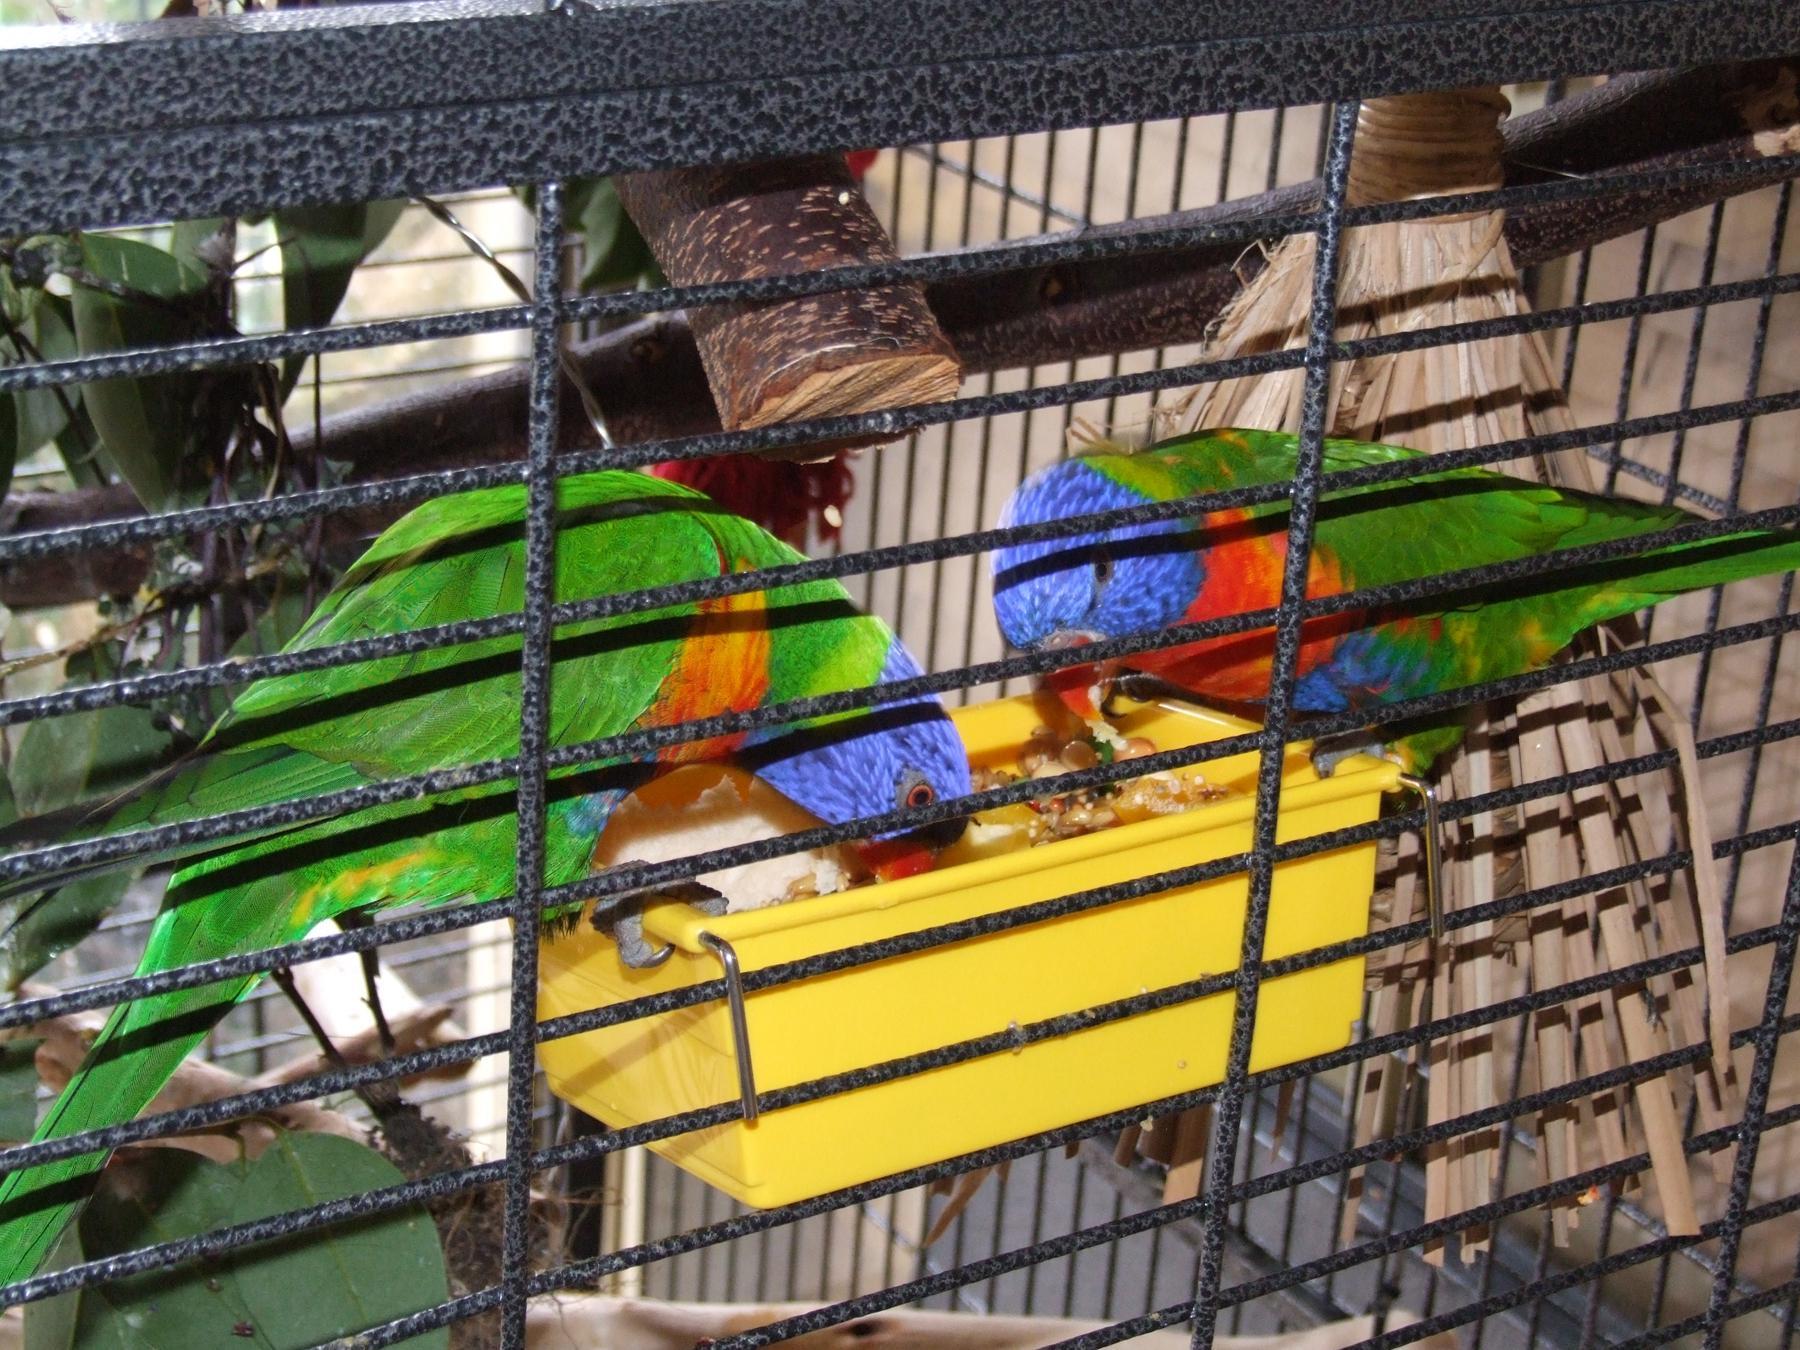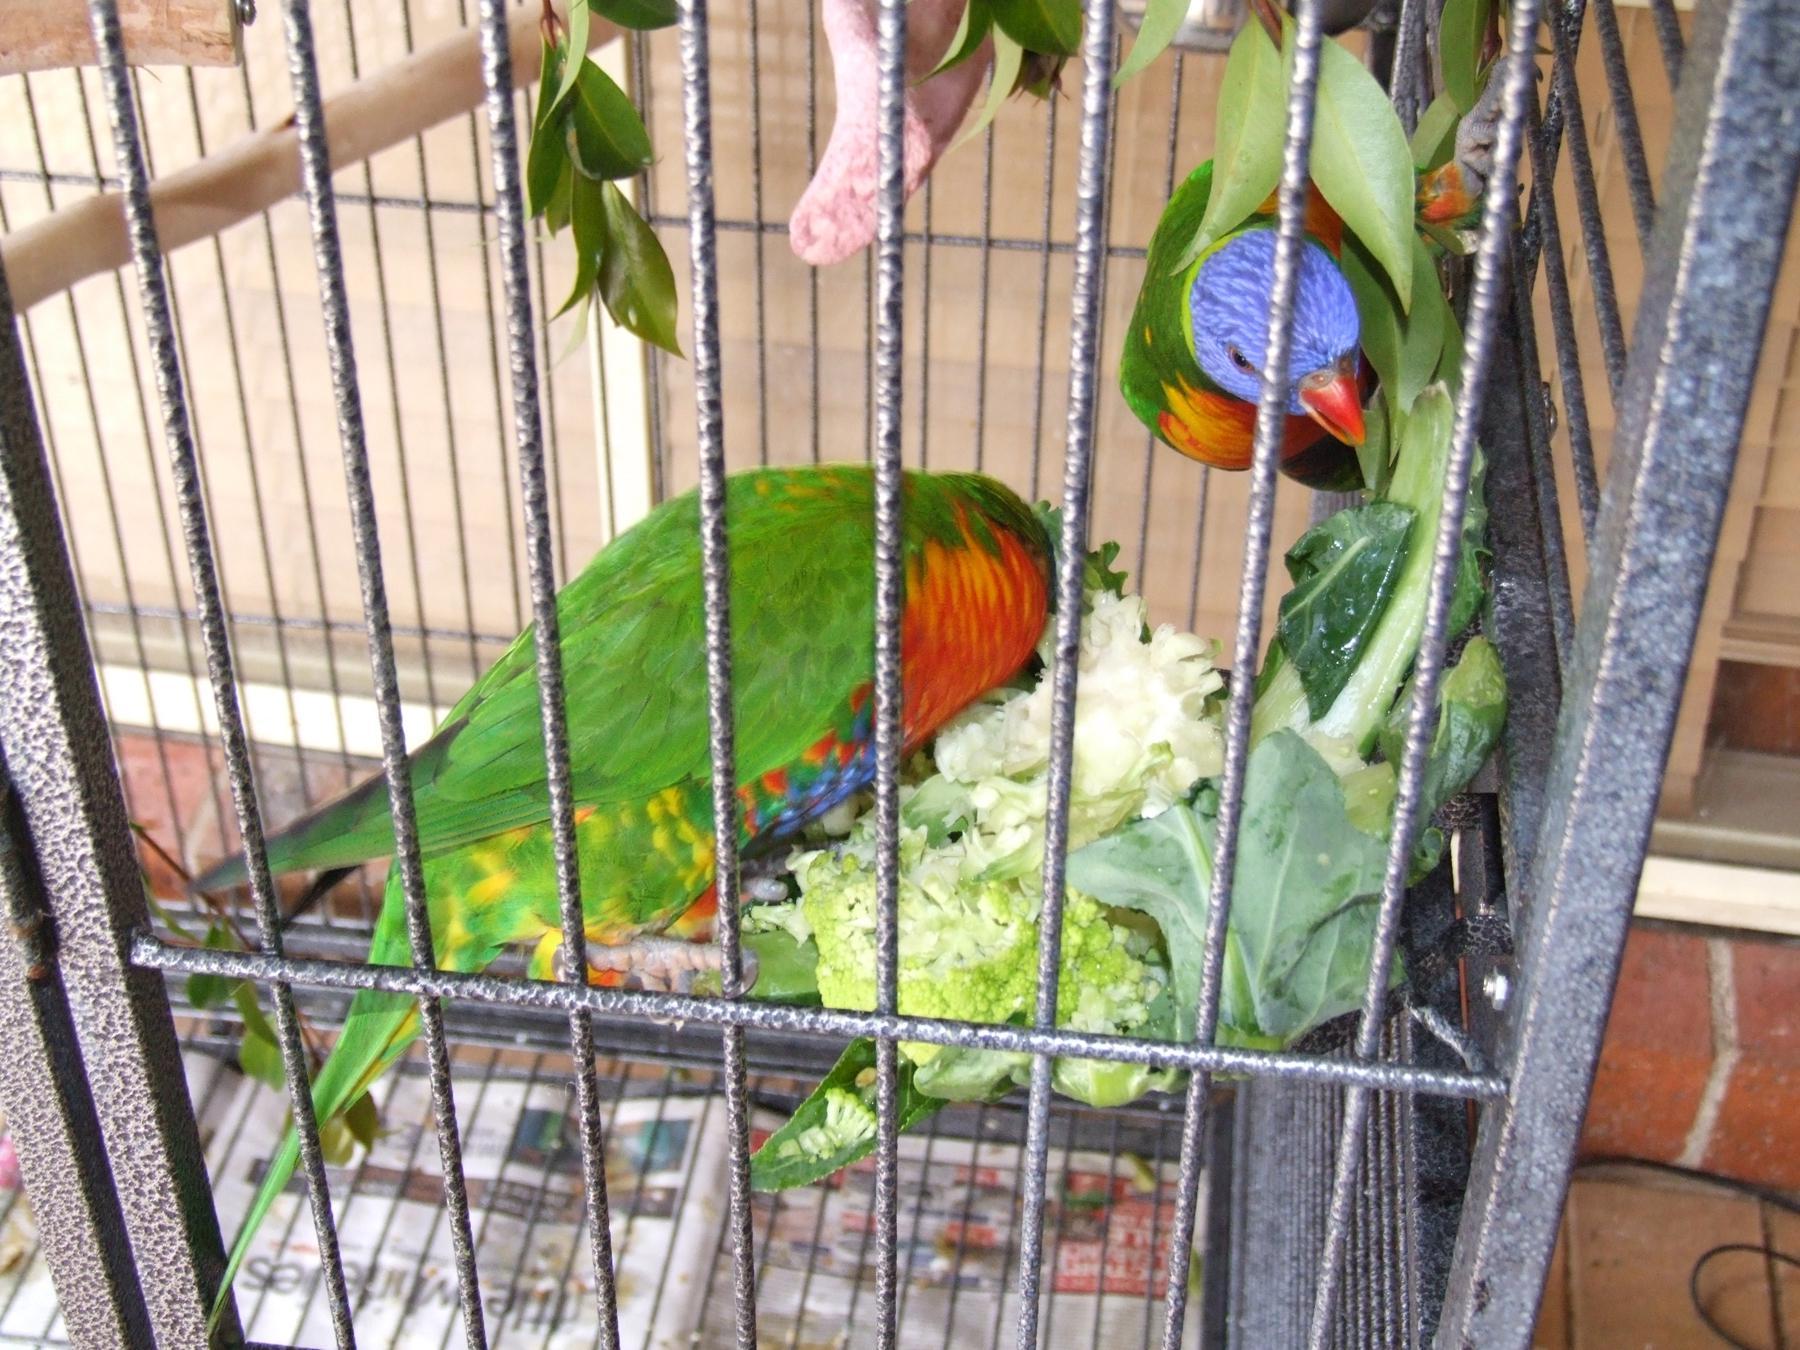The first image is the image on the left, the second image is the image on the right. Considering the images on both sides, is "Each image shows exactly two birds within a cage." valid? Answer yes or no. Yes. The first image is the image on the left, the second image is the image on the right. Analyze the images presented: Is the assertion "All of the birds have blue heads and orange/yellow bellies." valid? Answer yes or no. Yes. 